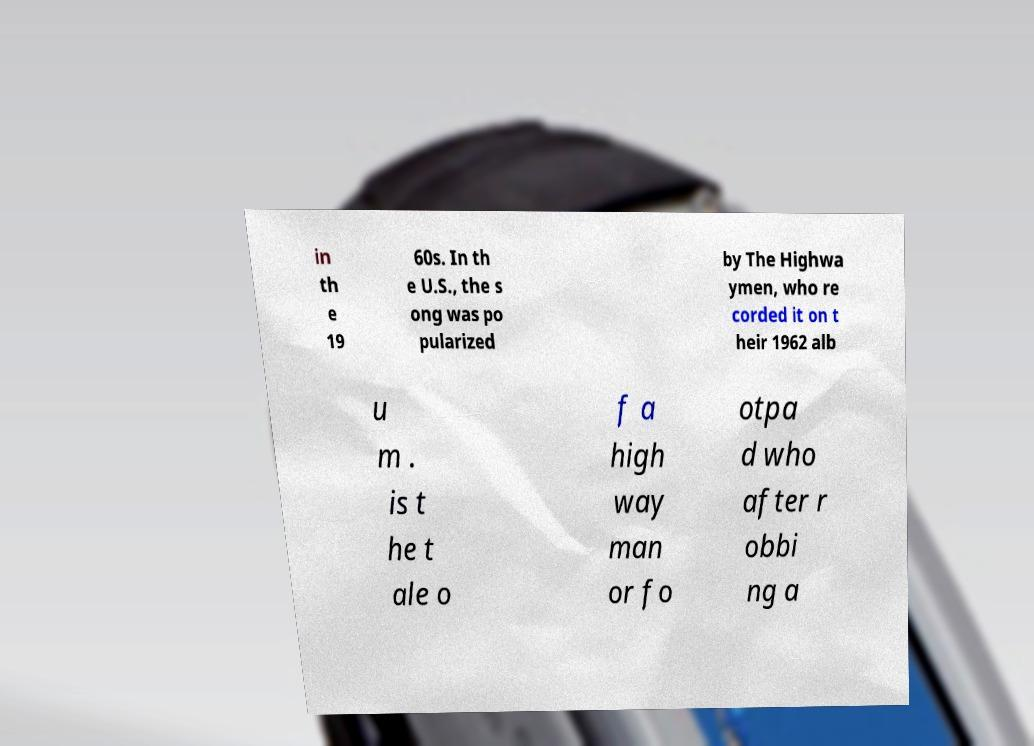Can you read and provide the text displayed in the image?This photo seems to have some interesting text. Can you extract and type it out for me? in th e 19 60s. In th e U.S., the s ong was po pularized by The Highwa ymen, who re corded it on t heir 1962 alb u m . is t he t ale o f a high way man or fo otpa d who after r obbi ng a 